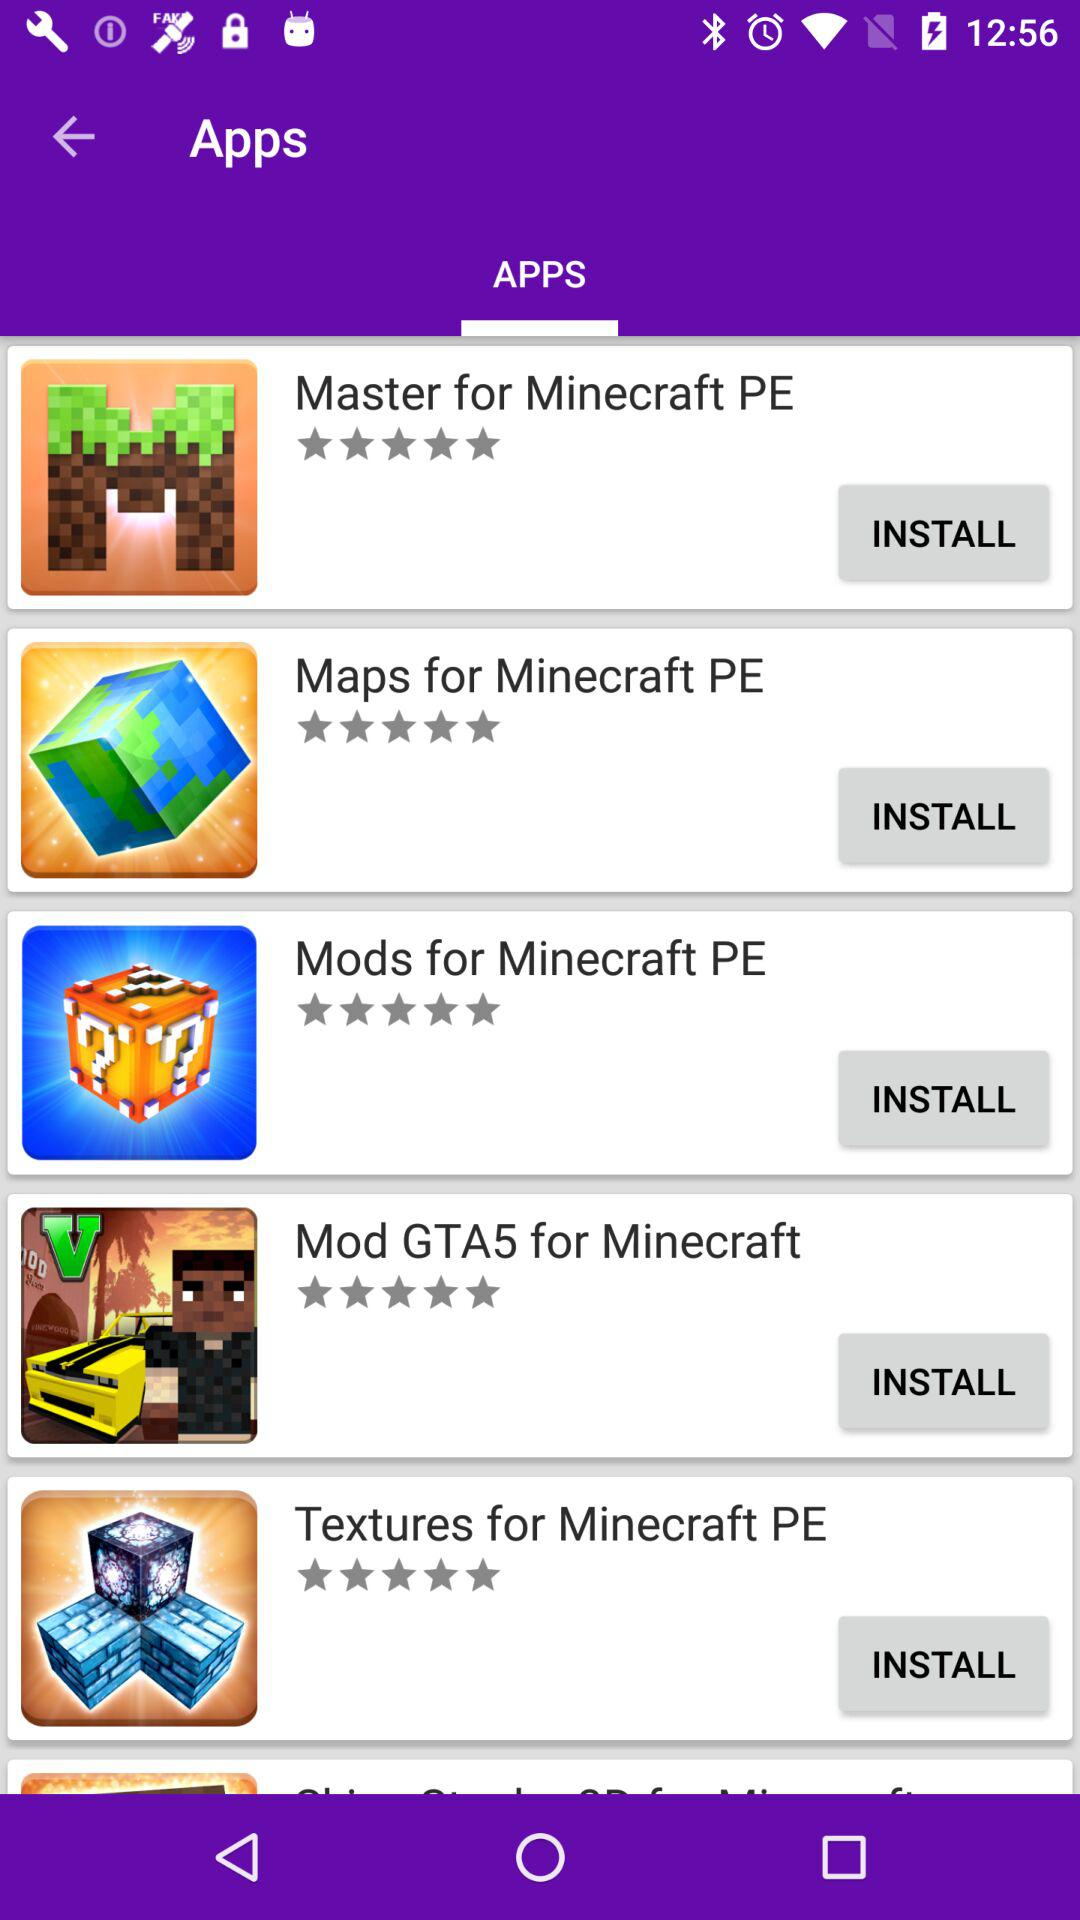Which tab is selected? The selected tab is "APPS". 